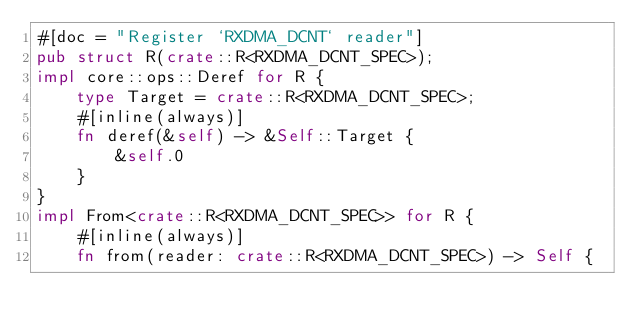<code> <loc_0><loc_0><loc_500><loc_500><_Rust_>#[doc = "Register `RXDMA_DCNT` reader"]
pub struct R(crate::R<RXDMA_DCNT_SPEC>);
impl core::ops::Deref for R {
    type Target = crate::R<RXDMA_DCNT_SPEC>;
    #[inline(always)]
    fn deref(&self) -> &Self::Target {
        &self.0
    }
}
impl From<crate::R<RXDMA_DCNT_SPEC>> for R {
    #[inline(always)]
    fn from(reader: crate::R<RXDMA_DCNT_SPEC>) -> Self {</code> 